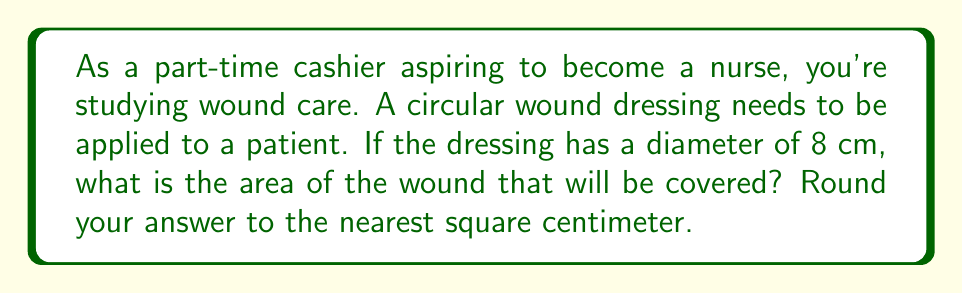Solve this math problem. To solve this problem, we need to follow these steps:

1. Identify the formula for the area of a circle:
   The area of a circle is given by the formula $A = \pi r^2$, where $A$ is the area and $r$ is the radius.

2. Determine the radius:
   We're given the diameter, which is 8 cm. The radius is half of the diameter.
   $r = \frac{diameter}{2} = \frac{8}{2} = 4$ cm

3. Apply the formula:
   $$A = \pi r^2$$
   $$A = \pi (4)^2$$
   $$A = 16\pi \text{ cm}^2$$

4. Calculate and round to the nearest square centimeter:
   $$A \approx 16 \times 3.14159 \text{ cm}^2$$
   $$A \approx 50.27 \text{ cm}^2$$

   Rounding to the nearest square centimeter: 50 cm²

This calculation gives us the area of the circular wound dressing, which represents the area of the wound that will be covered.
Answer: 50 cm² 